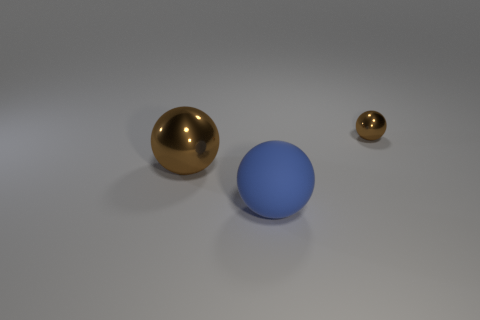Add 3 large yellow metal spheres. How many objects exist? 6 Subtract all big gray rubber balls. Subtract all tiny brown metal balls. How many objects are left? 2 Add 2 large balls. How many large balls are left? 4 Add 2 small red shiny blocks. How many small red shiny blocks exist? 2 Subtract 0 cyan cylinders. How many objects are left? 3 